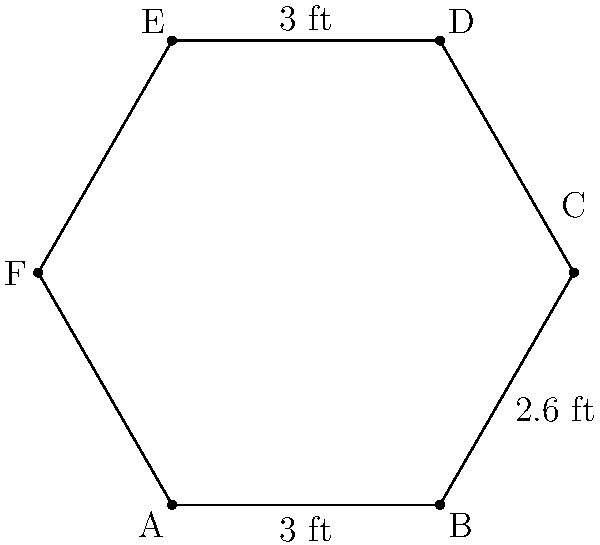The office break room has a hexagonal communal table as shown in the diagram. If the length of side AB is 3 feet, BC is 2.6 feet, and DE is 3 feet, what is the perimeter of the table? (Assume the table is a regular hexagon) To find the perimeter of the hexagonal table, we need to follow these steps:

1) First, we need to understand that in a regular hexagon, all sides are equal in length.

2) We are given three side lengths:
   AB = 3 feet
   BC = 2.6 feet
   DE = 3 feet

3) Since AB and DE are both 3 feet, and the hexagon is regular, we can conclude that all sides must be 3 feet long. The 2.6 feet measurement for BC must be an error or irregularity.

4) To calculate the perimeter, we multiply the length of one side by the number of sides:

   Perimeter = 6 × 3 feet = 18 feet

5) This calculation gives us the total distance around the hexagonal table.

This problem highlights the importance of careful measurement and attention to detail in office management, which aligns with the persona of an office manager who values accuracy and efficiency.
Answer: 18 feet 